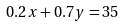Convert formula to latex. <formula><loc_0><loc_0><loc_500><loc_500>0 . 2 x + 0 . 7 y = 3 5</formula> 